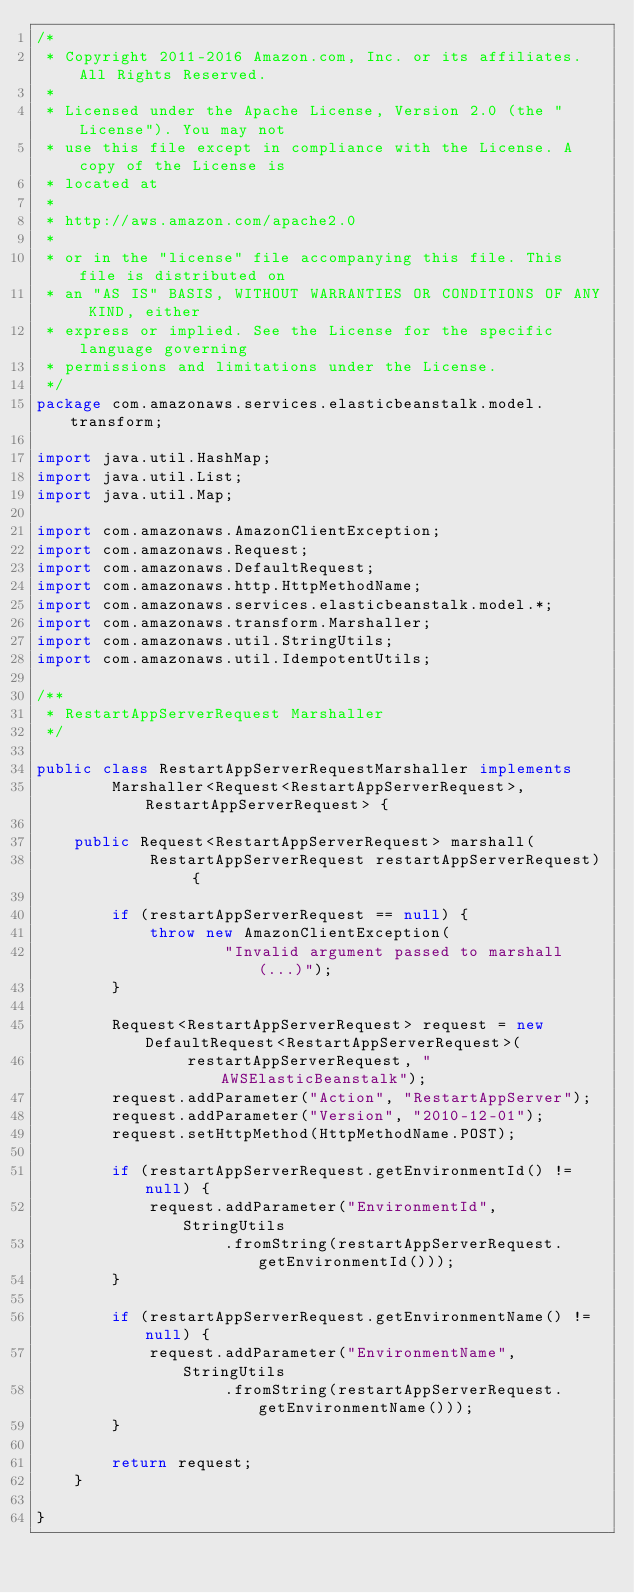Convert code to text. <code><loc_0><loc_0><loc_500><loc_500><_Java_>/*
 * Copyright 2011-2016 Amazon.com, Inc. or its affiliates. All Rights Reserved.
 * 
 * Licensed under the Apache License, Version 2.0 (the "License"). You may not
 * use this file except in compliance with the License. A copy of the License is
 * located at
 * 
 * http://aws.amazon.com/apache2.0
 * 
 * or in the "license" file accompanying this file. This file is distributed on
 * an "AS IS" BASIS, WITHOUT WARRANTIES OR CONDITIONS OF ANY KIND, either
 * express or implied. See the License for the specific language governing
 * permissions and limitations under the License.
 */
package com.amazonaws.services.elasticbeanstalk.model.transform;

import java.util.HashMap;
import java.util.List;
import java.util.Map;

import com.amazonaws.AmazonClientException;
import com.amazonaws.Request;
import com.amazonaws.DefaultRequest;
import com.amazonaws.http.HttpMethodName;
import com.amazonaws.services.elasticbeanstalk.model.*;
import com.amazonaws.transform.Marshaller;
import com.amazonaws.util.StringUtils;
import com.amazonaws.util.IdempotentUtils;

/**
 * RestartAppServerRequest Marshaller
 */

public class RestartAppServerRequestMarshaller implements
        Marshaller<Request<RestartAppServerRequest>, RestartAppServerRequest> {

    public Request<RestartAppServerRequest> marshall(
            RestartAppServerRequest restartAppServerRequest) {

        if (restartAppServerRequest == null) {
            throw new AmazonClientException(
                    "Invalid argument passed to marshall(...)");
        }

        Request<RestartAppServerRequest> request = new DefaultRequest<RestartAppServerRequest>(
                restartAppServerRequest, "AWSElasticBeanstalk");
        request.addParameter("Action", "RestartAppServer");
        request.addParameter("Version", "2010-12-01");
        request.setHttpMethod(HttpMethodName.POST);

        if (restartAppServerRequest.getEnvironmentId() != null) {
            request.addParameter("EnvironmentId", StringUtils
                    .fromString(restartAppServerRequest.getEnvironmentId()));
        }

        if (restartAppServerRequest.getEnvironmentName() != null) {
            request.addParameter("EnvironmentName", StringUtils
                    .fromString(restartAppServerRequest.getEnvironmentName()));
        }

        return request;
    }

}
</code> 